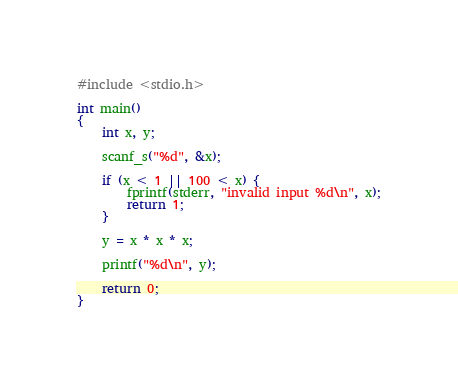Convert code to text. <code><loc_0><loc_0><loc_500><loc_500><_C_>#include <stdio.h>

int main()
{
	int x, y;

	scanf_s("%d", &x);

	if (x < 1 || 100 < x) {
		fprintf(stderr, "invalid input %d\n", x);
		return 1;
	}

	y = x * x * x;

	printf("%d\n", y);

	return 0;
}
</code> 